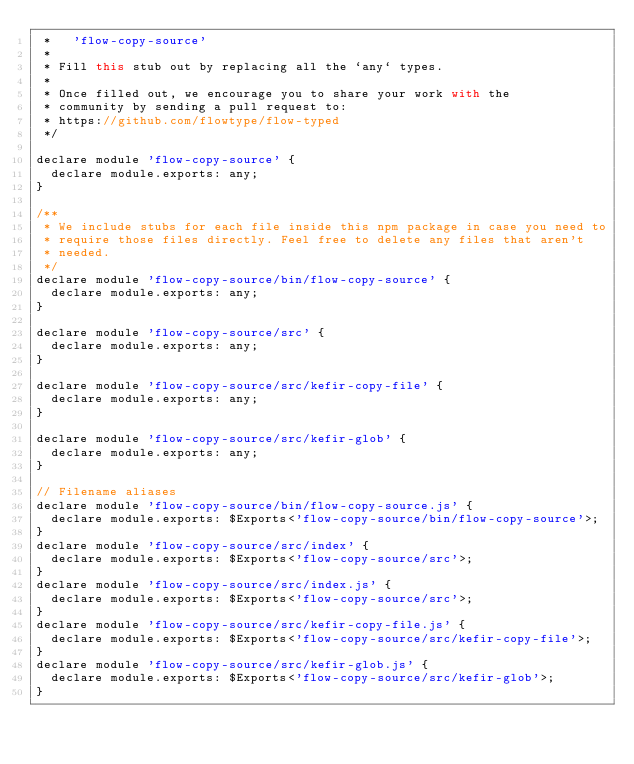Convert code to text. <code><loc_0><loc_0><loc_500><loc_500><_JavaScript_> *   'flow-copy-source'
 *
 * Fill this stub out by replacing all the `any` types.
 *
 * Once filled out, we encourage you to share your work with the
 * community by sending a pull request to:
 * https://github.com/flowtype/flow-typed
 */

declare module 'flow-copy-source' {
  declare module.exports: any;
}

/**
 * We include stubs for each file inside this npm package in case you need to
 * require those files directly. Feel free to delete any files that aren't
 * needed.
 */
declare module 'flow-copy-source/bin/flow-copy-source' {
  declare module.exports: any;
}

declare module 'flow-copy-source/src' {
  declare module.exports: any;
}

declare module 'flow-copy-source/src/kefir-copy-file' {
  declare module.exports: any;
}

declare module 'flow-copy-source/src/kefir-glob' {
  declare module.exports: any;
}

// Filename aliases
declare module 'flow-copy-source/bin/flow-copy-source.js' {
  declare module.exports: $Exports<'flow-copy-source/bin/flow-copy-source'>;
}
declare module 'flow-copy-source/src/index' {
  declare module.exports: $Exports<'flow-copy-source/src'>;
}
declare module 'flow-copy-source/src/index.js' {
  declare module.exports: $Exports<'flow-copy-source/src'>;
}
declare module 'flow-copy-source/src/kefir-copy-file.js' {
  declare module.exports: $Exports<'flow-copy-source/src/kefir-copy-file'>;
}
declare module 'flow-copy-source/src/kefir-glob.js' {
  declare module.exports: $Exports<'flow-copy-source/src/kefir-glob'>;
}
</code> 